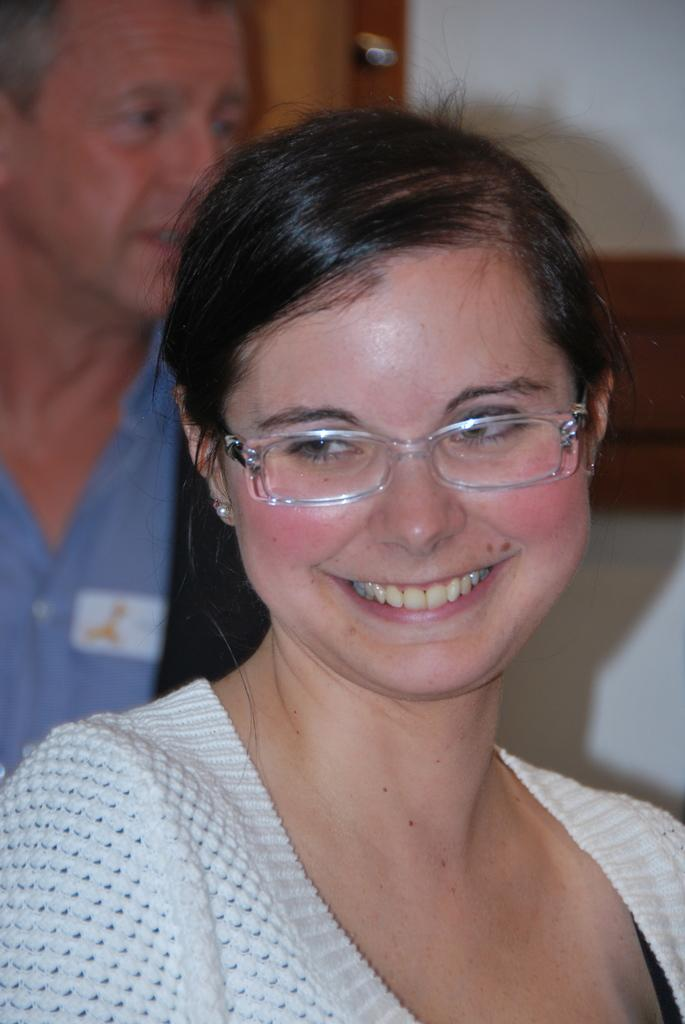Who is present in the image? There is a woman in the image. What is the woman doing in the image? The woman is smiling in the image. What accessory is the woman wearing? The woman is wearing spectacles in the image. Can you describe the background of the image? There is a man visible in the background of the image. What type of stem can be seen growing from the jar in the image? There is no jar or stem present in the image. 